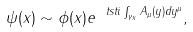<formula> <loc_0><loc_0><loc_500><loc_500>\psi ( x ) \sim \phi ( x ) e ^ { \ t s t i \int _ { \gamma _ { x } } A _ { \mu } ( y ) d y ^ { \mu } } ,</formula> 